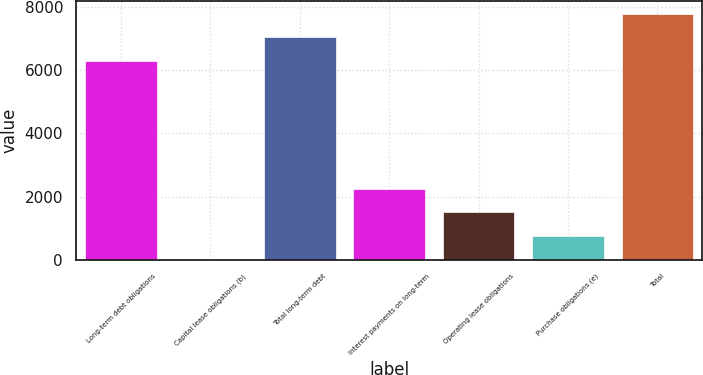Convert chart to OTSL. <chart><loc_0><loc_0><loc_500><loc_500><bar_chart><fcel>Long-term debt obligations<fcel>Capital lease obligations (b)<fcel>Total long-term debt<fcel>Interest payments on long-term<fcel>Operating lease obligations<fcel>Purchase obligations (e)<fcel>Total<nl><fcel>6308<fcel>1.4<fcel>7055.31<fcel>2243.33<fcel>1496.02<fcel>748.71<fcel>7802.62<nl></chart> 